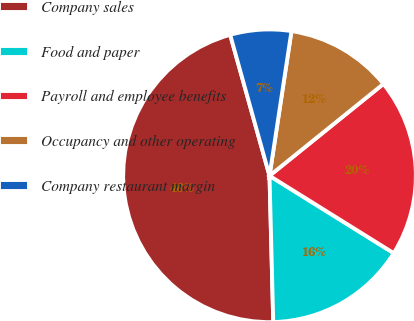<chart> <loc_0><loc_0><loc_500><loc_500><pie_chart><fcel>Company sales<fcel>Food and paper<fcel>Payroll and employee benefits<fcel>Occupancy and other operating<fcel>Company restaurant margin<nl><fcel>46.08%<fcel>15.73%<fcel>19.67%<fcel>11.8%<fcel>6.73%<nl></chart> 